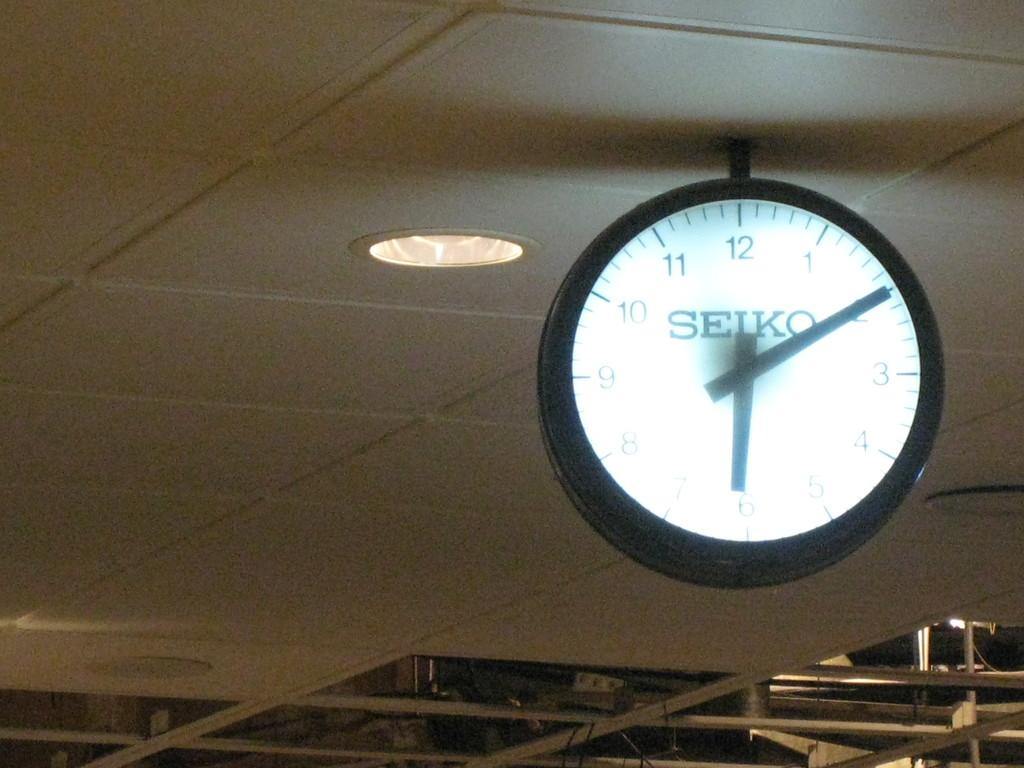Provide a one-sentence caption for the provided image. The Seiko clock hanging from the ceiling indicates it is ten minutes past six. 